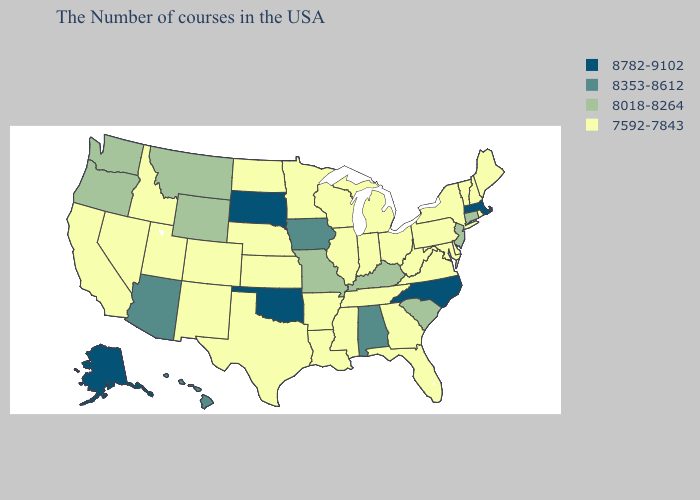Does South Dakota have a higher value than Kansas?
Concise answer only. Yes. What is the lowest value in the Northeast?
Short answer required. 7592-7843. Name the states that have a value in the range 8018-8264?
Short answer required. Connecticut, New Jersey, South Carolina, Kentucky, Missouri, Wyoming, Montana, Washington, Oregon. Does North Dakota have the highest value in the MidWest?
Write a very short answer. No. Name the states that have a value in the range 8782-9102?
Concise answer only. Massachusetts, North Carolina, Oklahoma, South Dakota, Alaska. What is the value of West Virginia?
Quick response, please. 7592-7843. Among the states that border New Hampshire , which have the lowest value?
Answer briefly. Maine, Vermont. What is the value of Idaho?
Be succinct. 7592-7843. What is the highest value in the Northeast ?
Be succinct. 8782-9102. What is the value of Minnesota?
Short answer required. 7592-7843. Does Florida have a lower value than West Virginia?
Give a very brief answer. No. Name the states that have a value in the range 8018-8264?
Short answer required. Connecticut, New Jersey, South Carolina, Kentucky, Missouri, Wyoming, Montana, Washington, Oregon. Among the states that border Idaho , does Wyoming have the highest value?
Answer briefly. Yes. What is the value of Minnesota?
Short answer required. 7592-7843. How many symbols are there in the legend?
Give a very brief answer. 4. 